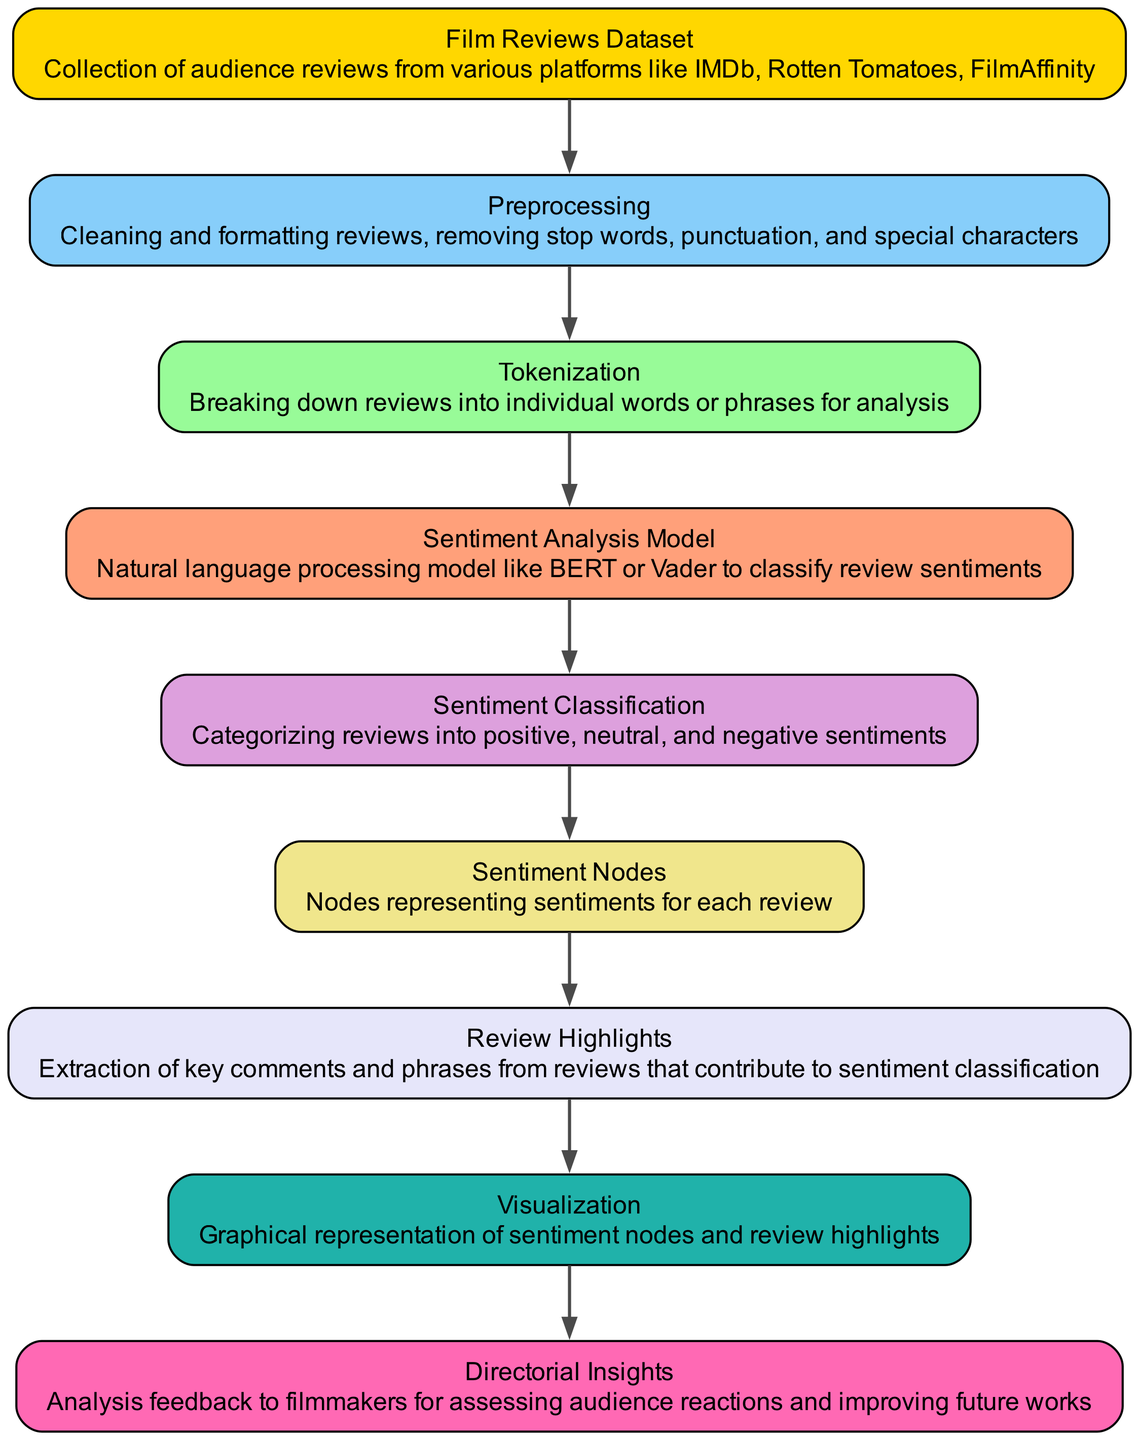What is the first node in the diagram? The diagram starts with the "Film Reviews Dataset" node, which represents the collection of audience reviews from various platforms.
Answer: Film Reviews Dataset How many edges are in the diagram? By counting the connections between nodes represented as edges in the diagram, there are eight edges total.
Answer: 8 What node follows "Preprocessing"? The "Tokenization" node comes next, indicating that after reviews are preprocessed, they are broken down into individual words or phrases.
Answer: Tokenization What does the "Visualization" node represent? The "Visualization" node represents the graphical representation of sentiment nodes and review highlights, which helps in understanding sentiments visually.
Answer: Graphical representation of sentiment nodes and review highlights Which sentiment classification node connects to "Review Highlights"? The "Sentiment Nodes" node connects to "Review Highlights," showing that the extracted comments and phrases contribute to the classification of sentiments.
Answer: Sentiment Nodes What is the final outcome node of the diagram? The last node in the flow of the diagram is "Directorial Insights," which captures the insights that filmmakers can utilize for assessing audience reactions.
Answer: Directorial Insights How does "Sentiment Analysis Model" link to the classification of reviews? The "Sentiment Analysis Model" node leads to "Sentiment Classification," indicating that the analysis performed by the model results in categorizing the sentiments of the reviews.
Answer: Sentiment Classification What type of model is highlighted in the "Sentiment Analysis Model" node? The node specifies that it can utilize natural language processing models like BERT or Vader for analyzing sentiment in reviews.
Answer: BERT or Vader 